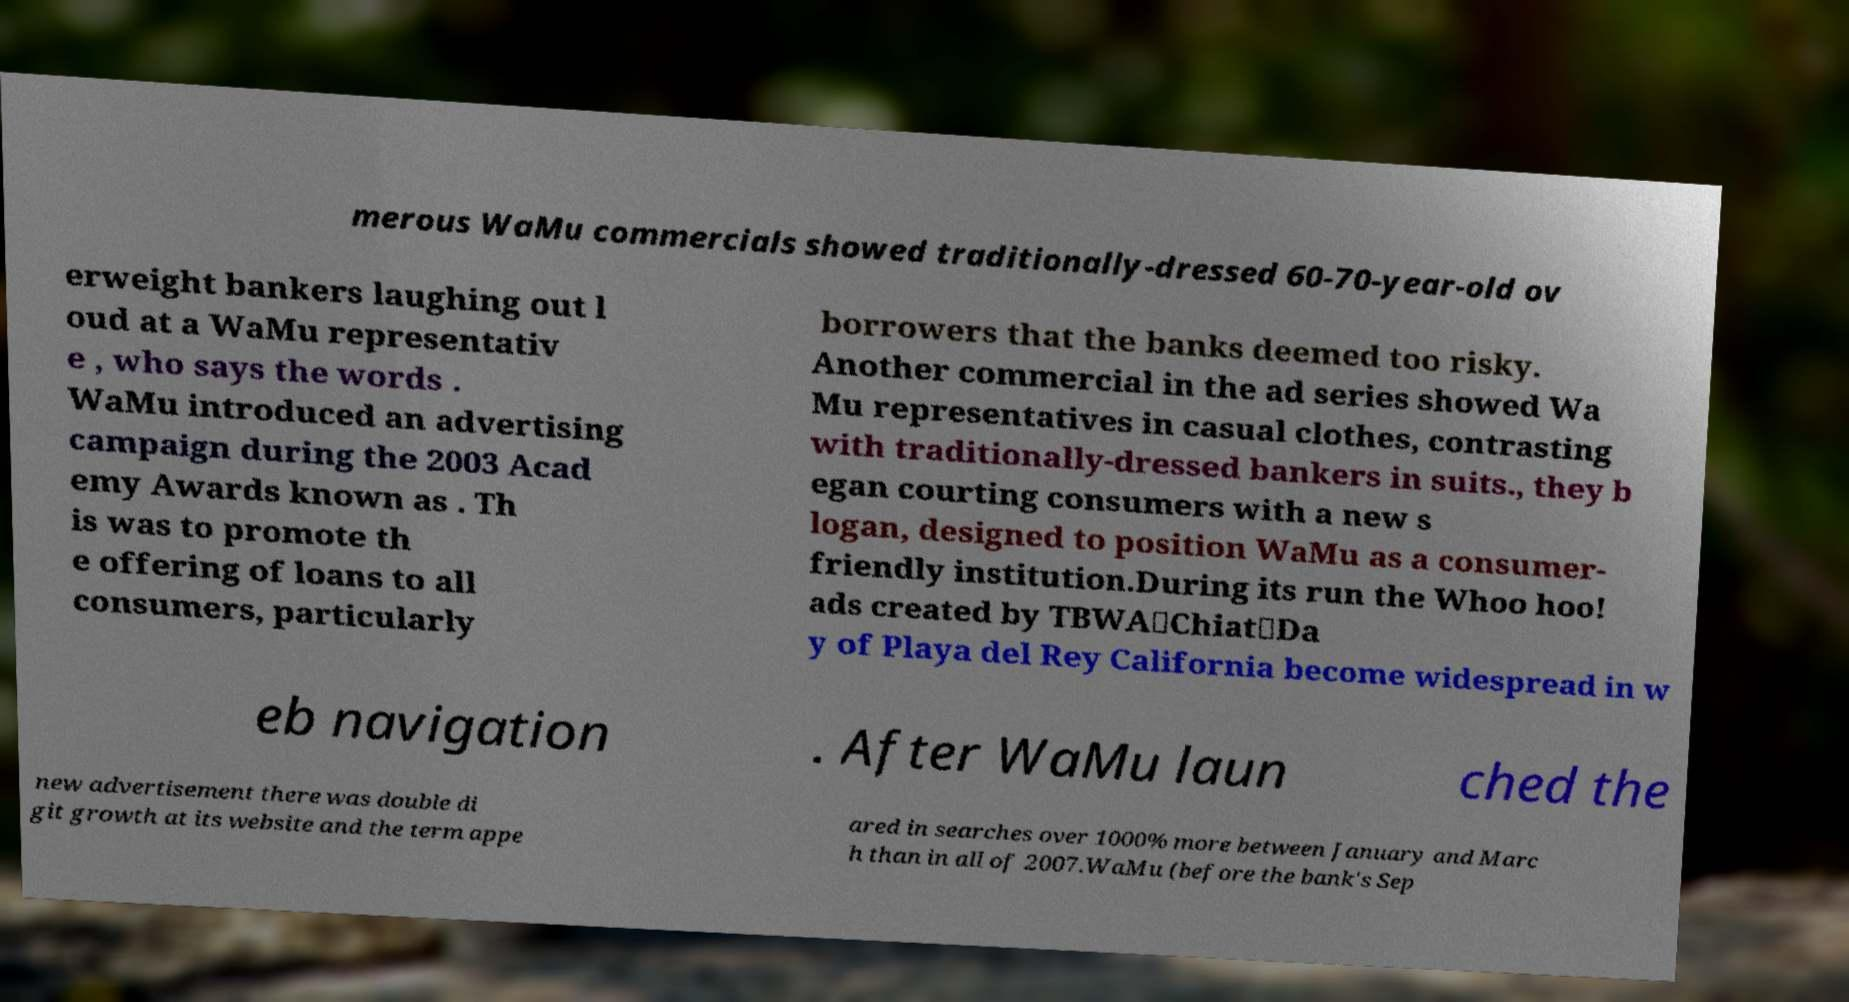Please identify and transcribe the text found in this image. merous WaMu commercials showed traditionally-dressed 60-70-year-old ov erweight bankers laughing out l oud at a WaMu representativ e , who says the words . WaMu introduced an advertising campaign during the 2003 Acad emy Awards known as . Th is was to promote th e offering of loans to all consumers, particularly borrowers that the banks deemed too risky. Another commercial in the ad series showed Wa Mu representatives in casual clothes, contrasting with traditionally-dressed bankers in suits., they b egan courting consumers with a new s logan, designed to position WaMu as a consumer- friendly institution.During its run the Whoo hoo! ads created by TBWA\Chiat\Da y of Playa del Rey California become widespread in w eb navigation . After WaMu laun ched the new advertisement there was double di git growth at its website and the term appe ared in searches over 1000% more between January and Marc h than in all of 2007.WaMu (before the bank's Sep 